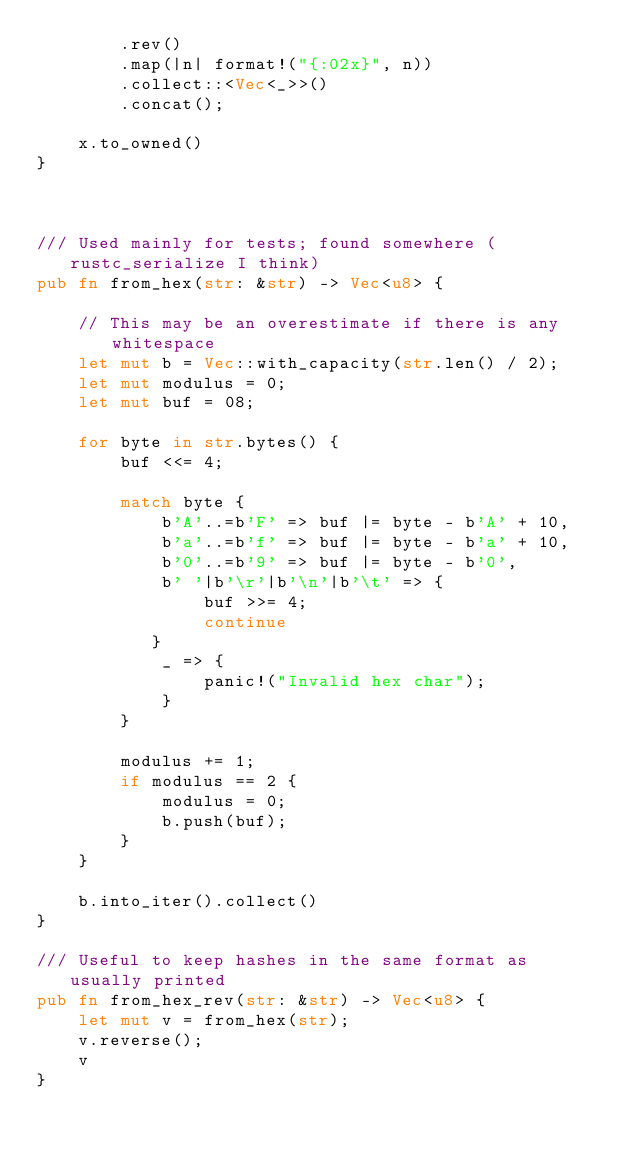Convert code to text. <code><loc_0><loc_0><loc_500><loc_500><_Rust_>        .rev()
        .map(|n| format!("{:02x}", n))
        .collect::<Vec<_>>()
        .concat();

    x.to_owned()
}



/// Used mainly for tests; found somewhere (rustc_serialize I think)
pub fn from_hex(str: &str) -> Vec<u8> {

    // This may be an overestimate if there is any whitespace
    let mut b = Vec::with_capacity(str.len() / 2);
    let mut modulus = 0;
    let mut buf = 08;

    for byte in str.bytes() {
        buf <<= 4;

        match byte {
            b'A'..=b'F' => buf |= byte - b'A' + 10,
            b'a'..=b'f' => buf |= byte - b'a' + 10,
            b'0'..=b'9' => buf |= byte - b'0',
            b' '|b'\r'|b'\n'|b'\t' => {
                buf >>= 4;
                continue
           }
            _ => {
                panic!("Invalid hex char");
            }
        }

        modulus += 1;
        if modulus == 2 {
            modulus = 0;
            b.push(buf);
        }
    }

    b.into_iter().collect()
}

/// Useful to keep hashes in the same format as usually printed
pub fn from_hex_rev(str: &str) -> Vec<u8> {
    let mut v = from_hex(str);
    v.reverse();
    v
}
</code> 